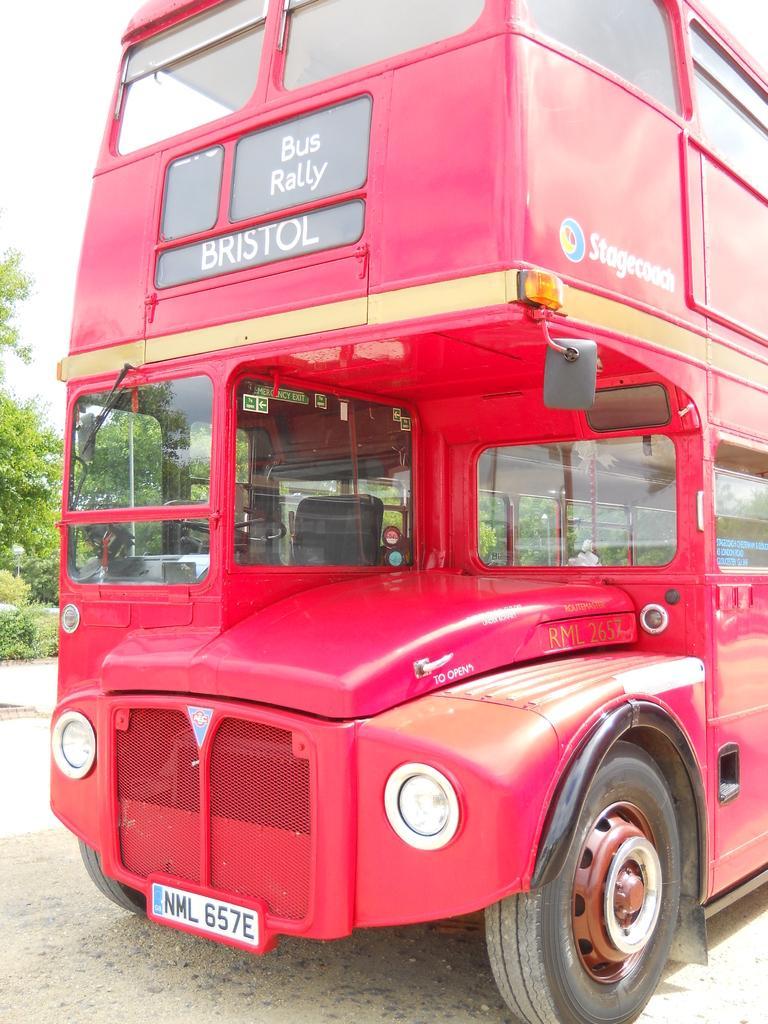How would you summarize this image in a sentence or two? In this picture I can see a Double Decker bus on the road, there are trees, and in the background there is sky. 